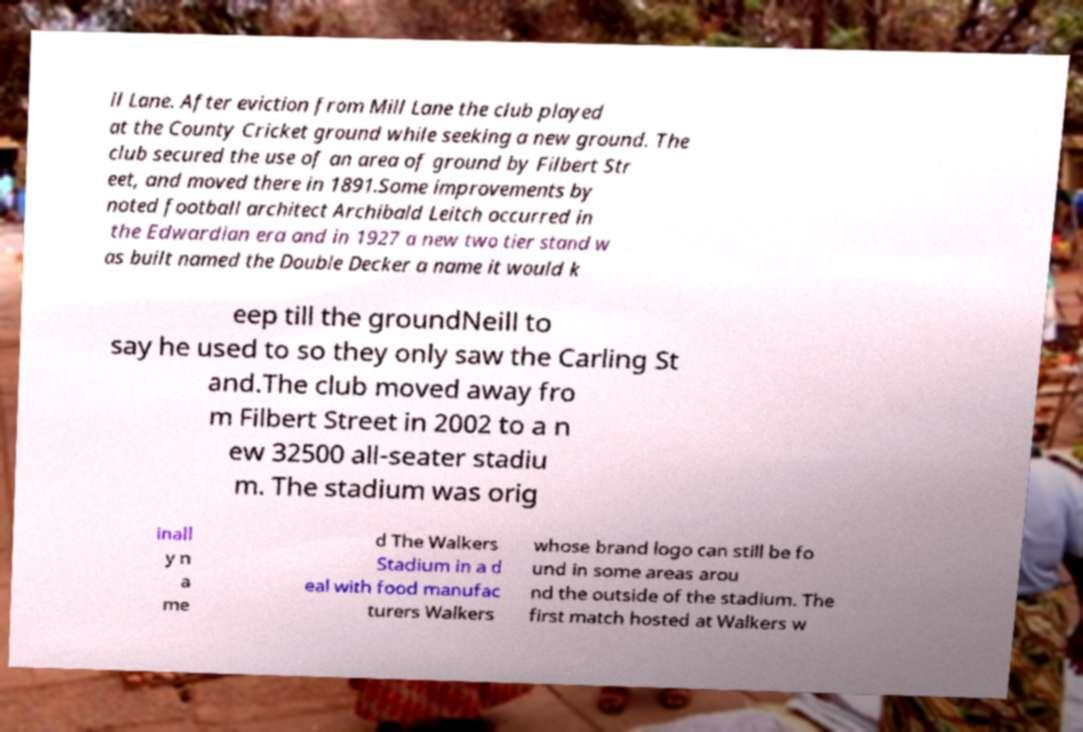I need the written content from this picture converted into text. Can you do that? ll Lane. After eviction from Mill Lane the club played at the County Cricket ground while seeking a new ground. The club secured the use of an area of ground by Filbert Str eet, and moved there in 1891.Some improvements by noted football architect Archibald Leitch occurred in the Edwardian era and in 1927 a new two tier stand w as built named the Double Decker a name it would k eep till the groundNeill to say he used to so they only saw the Carling St and.The club moved away fro m Filbert Street in 2002 to a n ew 32500 all-seater stadiu m. The stadium was orig inall y n a me d The Walkers Stadium in a d eal with food manufac turers Walkers whose brand logo can still be fo und in some areas arou nd the outside of the stadium. The first match hosted at Walkers w 